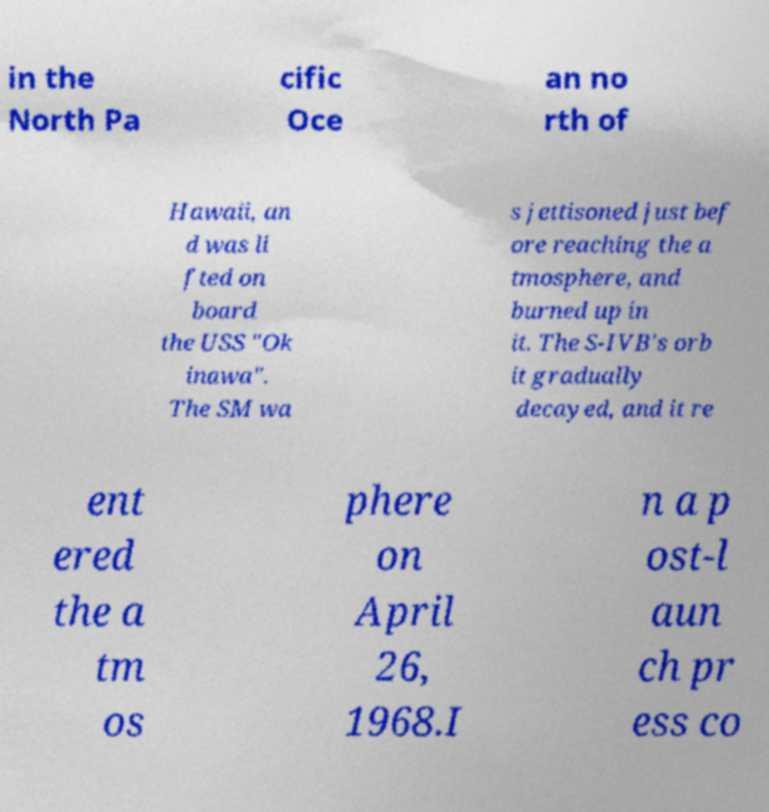Can you accurately transcribe the text from the provided image for me? in the North Pa cific Oce an no rth of Hawaii, an d was li fted on board the USS "Ok inawa". The SM wa s jettisoned just bef ore reaching the a tmosphere, and burned up in it. The S-IVB's orb it gradually decayed, and it re ent ered the a tm os phere on April 26, 1968.I n a p ost-l aun ch pr ess co 